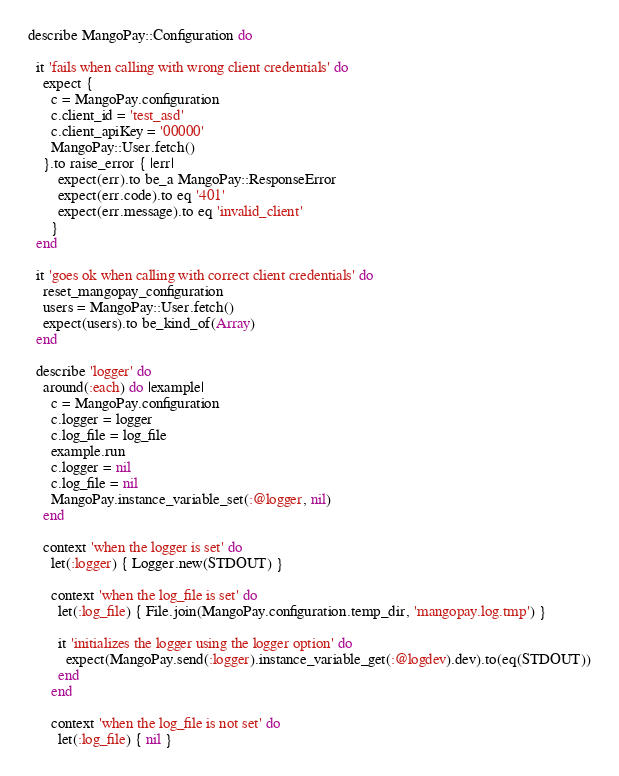Convert code to text. <code><loc_0><loc_0><loc_500><loc_500><_Ruby_>describe MangoPay::Configuration do

  it 'fails when calling with wrong client credentials' do
    expect {
      c = MangoPay.configuration
      c.client_id = 'test_asd'
      c.client_apiKey = '00000'
      MangoPay::User.fetch()
    }.to raise_error { |err|
        expect(err).to be_a MangoPay::ResponseError
        expect(err.code).to eq '401'
        expect(err.message).to eq 'invalid_client'
      }
  end

  it 'goes ok when calling with correct client credentials' do
    reset_mangopay_configuration
    users = MangoPay::User.fetch()
    expect(users).to be_kind_of(Array)
  end

  describe 'logger' do
    around(:each) do |example|
      c = MangoPay.configuration
      c.logger = logger
      c.log_file = log_file
      example.run
      c.logger = nil
      c.log_file = nil
      MangoPay.instance_variable_set(:@logger, nil)
    end

    context 'when the logger is set' do
      let(:logger) { Logger.new(STDOUT) }

      context 'when the log_file is set' do
        let(:log_file) { File.join(MangoPay.configuration.temp_dir, 'mangopay.log.tmp') }

        it 'initializes the logger using the logger option' do
          expect(MangoPay.send(:logger).instance_variable_get(:@logdev).dev).to(eq(STDOUT))
        end
      end

      context 'when the log_file is not set' do
        let(:log_file) { nil }
</code> 